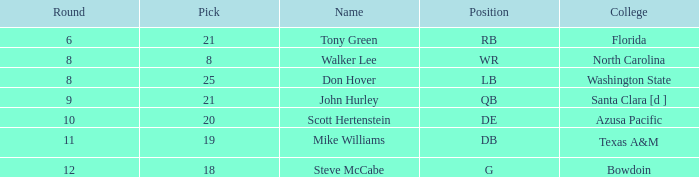How many overalls have a pick greater than 19, with florida as the college? 159.0. 